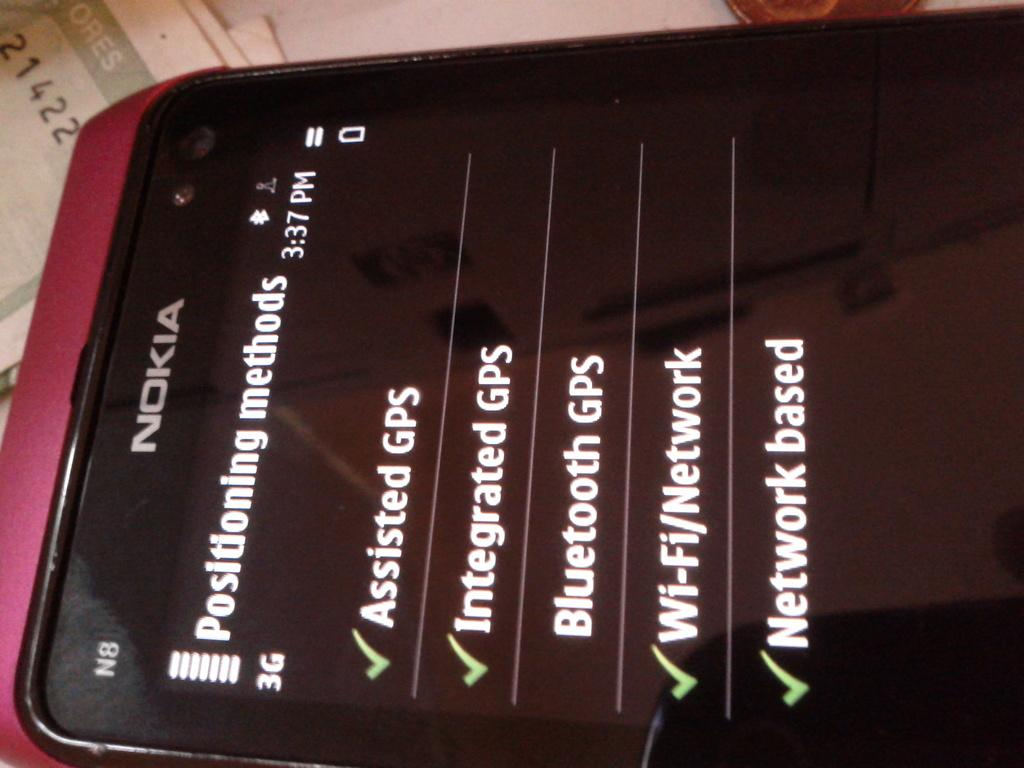<image>
Write a terse but informative summary of the picture. Several positioning methods are being shown on the screen of this Nokia phone. 